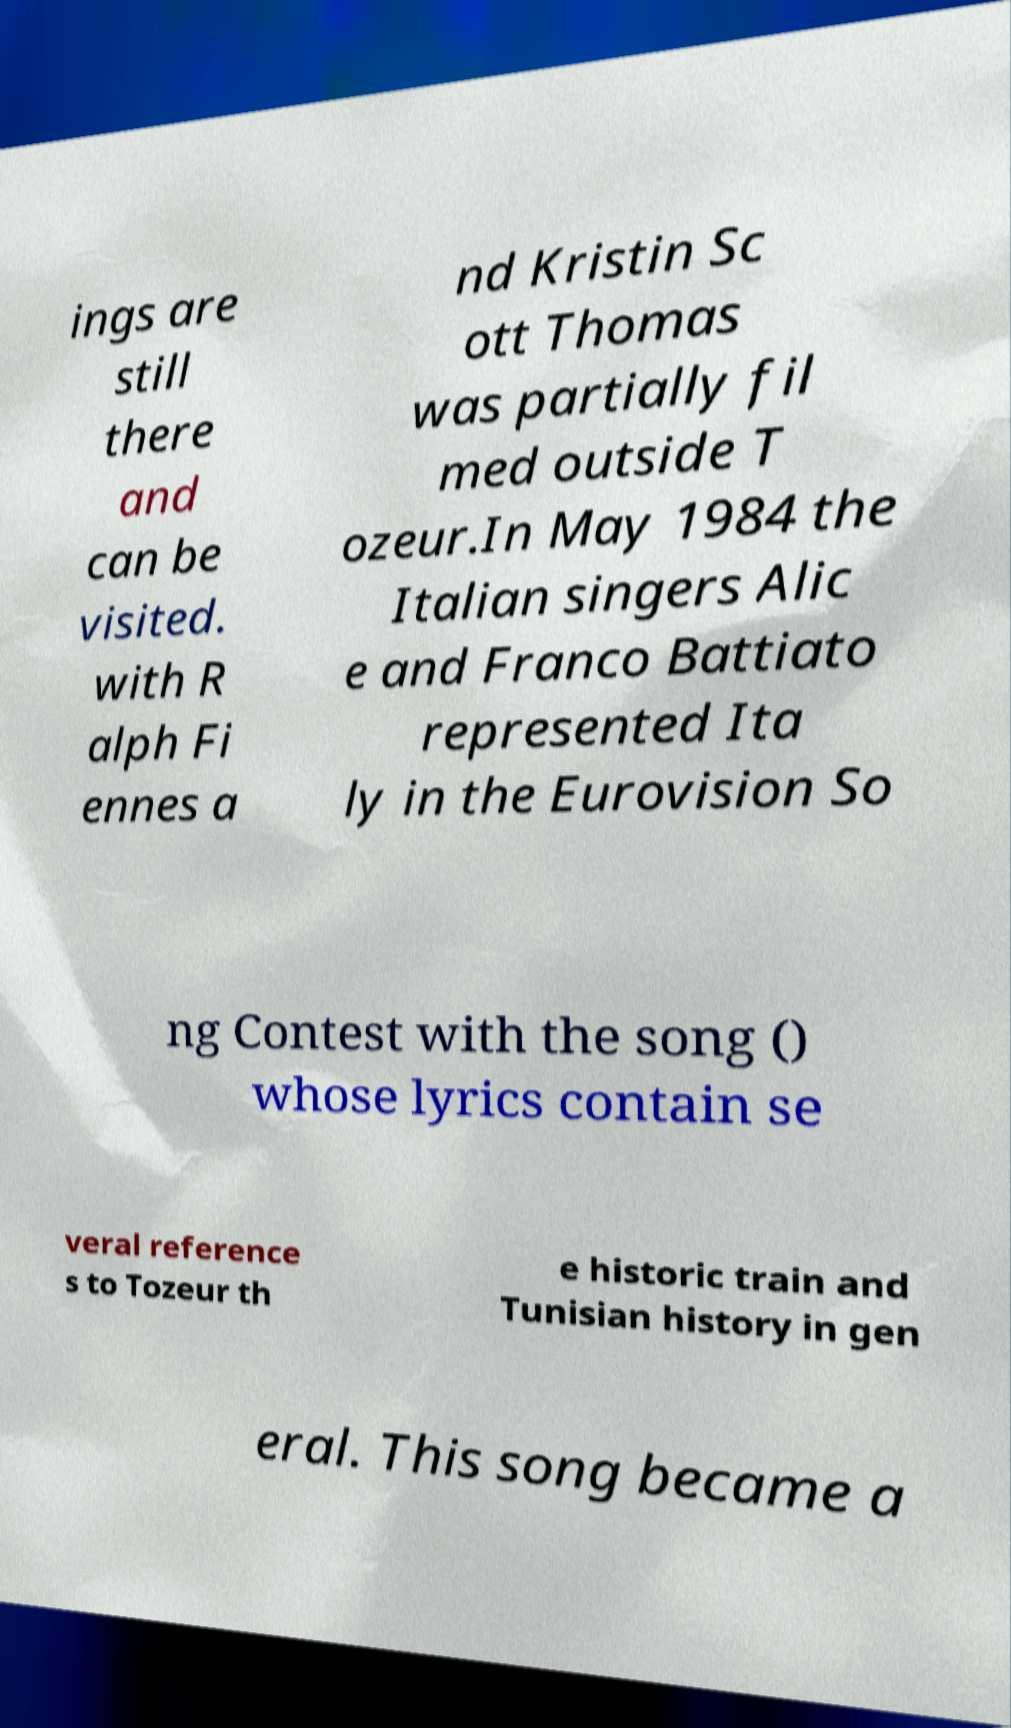For documentation purposes, I need the text within this image transcribed. Could you provide that? ings are still there and can be visited. with R alph Fi ennes a nd Kristin Sc ott Thomas was partially fil med outside T ozeur.In May 1984 the Italian singers Alic e and Franco Battiato represented Ita ly in the Eurovision So ng Contest with the song () whose lyrics contain se veral reference s to Tozeur th e historic train and Tunisian history in gen eral. This song became a 